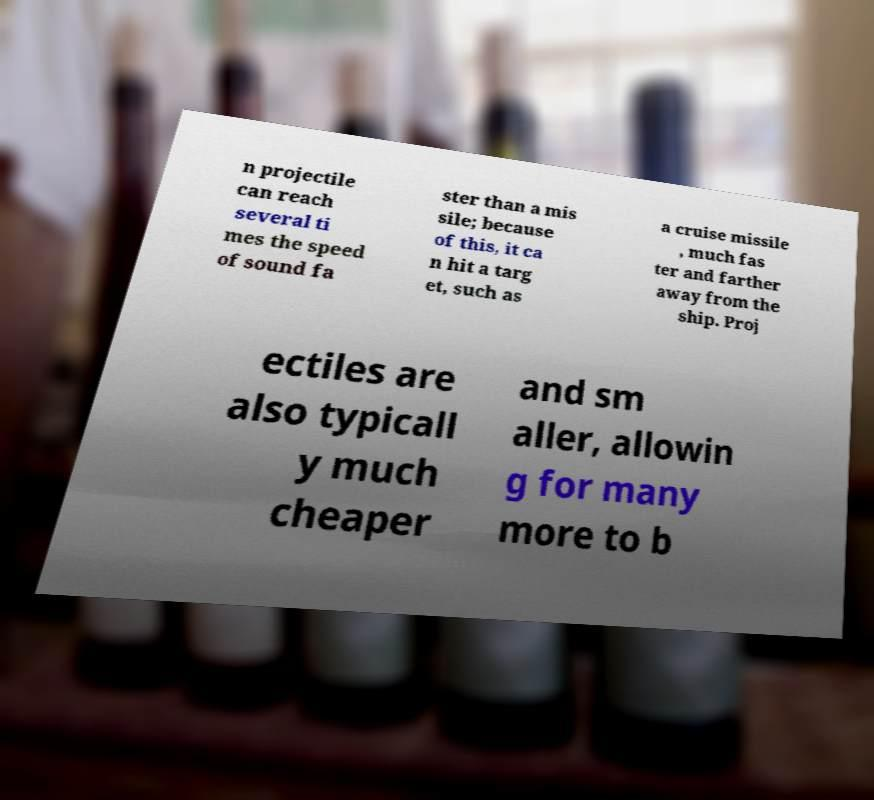Please read and relay the text visible in this image. What does it say? n projectile can reach several ti mes the speed of sound fa ster than a mis sile; because of this, it ca n hit a targ et, such as a cruise missile , much fas ter and farther away from the ship. Proj ectiles are also typicall y much cheaper and sm aller, allowin g for many more to b 